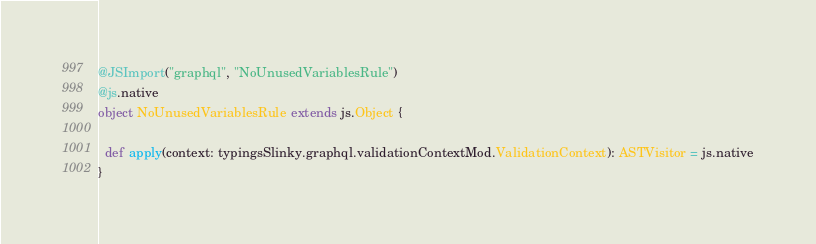Convert code to text. <code><loc_0><loc_0><loc_500><loc_500><_Scala_>@JSImport("graphql", "NoUnusedVariablesRule")
@js.native
object NoUnusedVariablesRule extends js.Object {
  
  def apply(context: typingsSlinky.graphql.validationContextMod.ValidationContext): ASTVisitor = js.native
}
</code> 